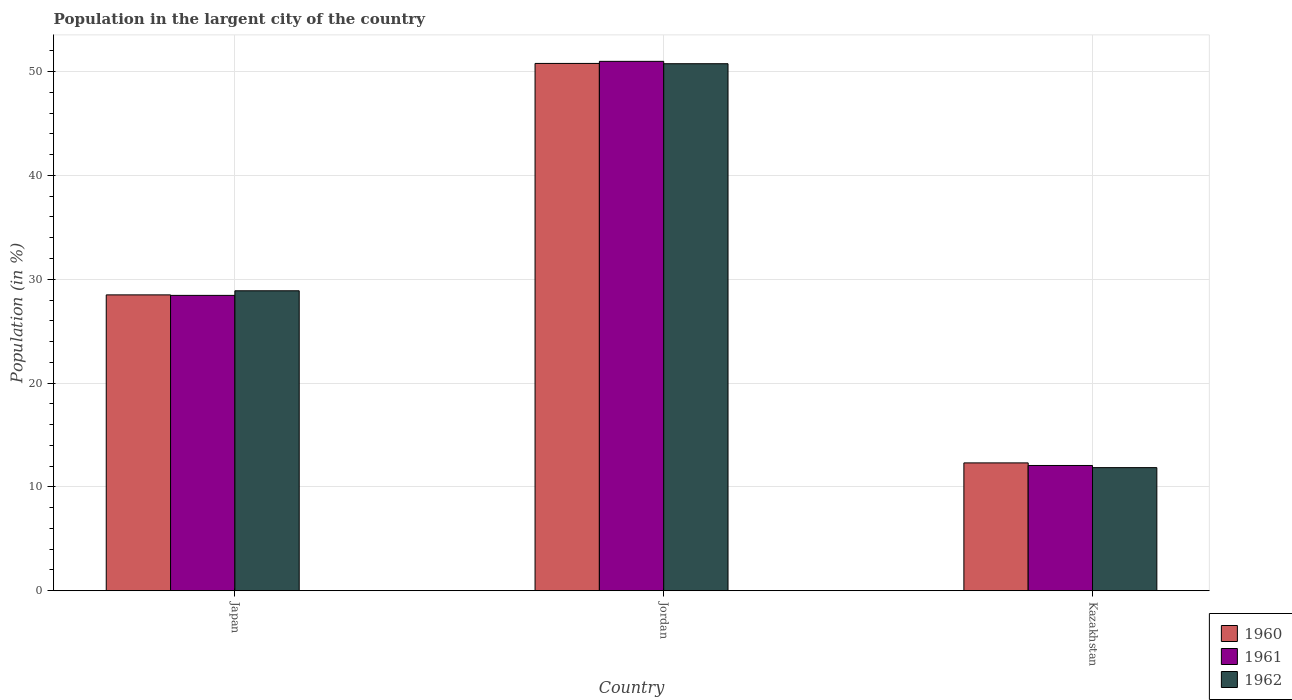How many groups of bars are there?
Provide a short and direct response. 3. Are the number of bars per tick equal to the number of legend labels?
Offer a terse response. Yes. How many bars are there on the 2nd tick from the right?
Ensure brevity in your answer.  3. In how many cases, is the number of bars for a given country not equal to the number of legend labels?
Offer a terse response. 0. What is the percentage of population in the largent city in 1960 in Jordan?
Make the answer very short. 50.79. Across all countries, what is the maximum percentage of population in the largent city in 1962?
Your answer should be very brief. 50.76. Across all countries, what is the minimum percentage of population in the largent city in 1961?
Provide a succinct answer. 12.06. In which country was the percentage of population in the largent city in 1962 maximum?
Your answer should be compact. Jordan. In which country was the percentage of population in the largent city in 1960 minimum?
Offer a terse response. Kazakhstan. What is the total percentage of population in the largent city in 1962 in the graph?
Give a very brief answer. 91.51. What is the difference between the percentage of population in the largent city in 1962 in Japan and that in Jordan?
Ensure brevity in your answer.  -21.87. What is the difference between the percentage of population in the largent city in 1960 in Kazakhstan and the percentage of population in the largent city in 1961 in Japan?
Offer a terse response. -16.14. What is the average percentage of population in the largent city in 1961 per country?
Keep it short and to the point. 30.5. What is the difference between the percentage of population in the largent city of/in 1962 and percentage of population in the largent city of/in 1960 in Kazakhstan?
Give a very brief answer. -0.46. What is the ratio of the percentage of population in the largent city in 1960 in Jordan to that in Kazakhstan?
Ensure brevity in your answer.  4.13. Is the percentage of population in the largent city in 1961 in Japan less than that in Jordan?
Make the answer very short. Yes. What is the difference between the highest and the second highest percentage of population in the largent city in 1961?
Provide a short and direct response. 22.54. What is the difference between the highest and the lowest percentage of population in the largent city in 1961?
Provide a succinct answer. 38.93. Is the sum of the percentage of population in the largent city in 1960 in Japan and Kazakhstan greater than the maximum percentage of population in the largent city in 1961 across all countries?
Provide a succinct answer. No. What does the 3rd bar from the left in Kazakhstan represents?
Offer a very short reply. 1962. What does the 1st bar from the right in Japan represents?
Ensure brevity in your answer.  1962. Are all the bars in the graph horizontal?
Provide a succinct answer. No. What is the difference between two consecutive major ticks on the Y-axis?
Provide a short and direct response. 10. What is the title of the graph?
Provide a succinct answer. Population in the largent city of the country. What is the label or title of the X-axis?
Keep it short and to the point. Country. What is the label or title of the Y-axis?
Your answer should be very brief. Population (in %). What is the Population (in %) in 1960 in Japan?
Your answer should be compact. 28.5. What is the Population (in %) of 1961 in Japan?
Provide a short and direct response. 28.45. What is the Population (in %) of 1962 in Japan?
Ensure brevity in your answer.  28.89. What is the Population (in %) of 1960 in Jordan?
Provide a short and direct response. 50.79. What is the Population (in %) in 1961 in Jordan?
Provide a succinct answer. 50.99. What is the Population (in %) of 1962 in Jordan?
Offer a very short reply. 50.76. What is the Population (in %) in 1960 in Kazakhstan?
Make the answer very short. 12.31. What is the Population (in %) in 1961 in Kazakhstan?
Offer a terse response. 12.06. What is the Population (in %) in 1962 in Kazakhstan?
Give a very brief answer. 11.86. Across all countries, what is the maximum Population (in %) of 1960?
Offer a very short reply. 50.79. Across all countries, what is the maximum Population (in %) in 1961?
Your answer should be compact. 50.99. Across all countries, what is the maximum Population (in %) of 1962?
Your response must be concise. 50.76. Across all countries, what is the minimum Population (in %) in 1960?
Your answer should be compact. 12.31. Across all countries, what is the minimum Population (in %) in 1961?
Ensure brevity in your answer.  12.06. Across all countries, what is the minimum Population (in %) of 1962?
Give a very brief answer. 11.86. What is the total Population (in %) of 1960 in the graph?
Make the answer very short. 91.6. What is the total Population (in %) in 1961 in the graph?
Offer a very short reply. 91.51. What is the total Population (in %) of 1962 in the graph?
Provide a succinct answer. 91.51. What is the difference between the Population (in %) of 1960 in Japan and that in Jordan?
Give a very brief answer. -22.29. What is the difference between the Population (in %) of 1961 in Japan and that in Jordan?
Provide a succinct answer. -22.54. What is the difference between the Population (in %) in 1962 in Japan and that in Jordan?
Offer a very short reply. -21.87. What is the difference between the Population (in %) in 1960 in Japan and that in Kazakhstan?
Provide a short and direct response. 16.18. What is the difference between the Population (in %) in 1961 in Japan and that in Kazakhstan?
Keep it short and to the point. 16.38. What is the difference between the Population (in %) of 1962 in Japan and that in Kazakhstan?
Offer a very short reply. 17.03. What is the difference between the Population (in %) of 1960 in Jordan and that in Kazakhstan?
Make the answer very short. 38.48. What is the difference between the Population (in %) of 1961 in Jordan and that in Kazakhstan?
Ensure brevity in your answer.  38.93. What is the difference between the Population (in %) in 1962 in Jordan and that in Kazakhstan?
Keep it short and to the point. 38.91. What is the difference between the Population (in %) of 1960 in Japan and the Population (in %) of 1961 in Jordan?
Make the answer very short. -22.5. What is the difference between the Population (in %) of 1960 in Japan and the Population (in %) of 1962 in Jordan?
Your answer should be compact. -22.27. What is the difference between the Population (in %) in 1961 in Japan and the Population (in %) in 1962 in Jordan?
Make the answer very short. -22.32. What is the difference between the Population (in %) in 1960 in Japan and the Population (in %) in 1961 in Kazakhstan?
Offer a very short reply. 16.43. What is the difference between the Population (in %) of 1960 in Japan and the Population (in %) of 1962 in Kazakhstan?
Provide a short and direct response. 16.64. What is the difference between the Population (in %) of 1961 in Japan and the Population (in %) of 1962 in Kazakhstan?
Provide a succinct answer. 16.59. What is the difference between the Population (in %) of 1960 in Jordan and the Population (in %) of 1961 in Kazakhstan?
Provide a succinct answer. 38.73. What is the difference between the Population (in %) of 1960 in Jordan and the Population (in %) of 1962 in Kazakhstan?
Make the answer very short. 38.94. What is the difference between the Population (in %) in 1961 in Jordan and the Population (in %) in 1962 in Kazakhstan?
Provide a succinct answer. 39.14. What is the average Population (in %) of 1960 per country?
Offer a terse response. 30.53. What is the average Population (in %) in 1961 per country?
Offer a very short reply. 30.5. What is the average Population (in %) in 1962 per country?
Give a very brief answer. 30.5. What is the difference between the Population (in %) of 1960 and Population (in %) of 1961 in Japan?
Keep it short and to the point. 0.05. What is the difference between the Population (in %) of 1960 and Population (in %) of 1962 in Japan?
Keep it short and to the point. -0.39. What is the difference between the Population (in %) in 1961 and Population (in %) in 1962 in Japan?
Provide a short and direct response. -0.44. What is the difference between the Population (in %) of 1960 and Population (in %) of 1961 in Jordan?
Your response must be concise. -0.2. What is the difference between the Population (in %) in 1960 and Population (in %) in 1962 in Jordan?
Provide a short and direct response. 0.03. What is the difference between the Population (in %) of 1961 and Population (in %) of 1962 in Jordan?
Provide a short and direct response. 0.23. What is the difference between the Population (in %) in 1960 and Population (in %) in 1961 in Kazakhstan?
Give a very brief answer. 0.25. What is the difference between the Population (in %) of 1960 and Population (in %) of 1962 in Kazakhstan?
Offer a terse response. 0.46. What is the difference between the Population (in %) of 1961 and Population (in %) of 1962 in Kazakhstan?
Offer a very short reply. 0.21. What is the ratio of the Population (in %) in 1960 in Japan to that in Jordan?
Keep it short and to the point. 0.56. What is the ratio of the Population (in %) in 1961 in Japan to that in Jordan?
Give a very brief answer. 0.56. What is the ratio of the Population (in %) in 1962 in Japan to that in Jordan?
Offer a very short reply. 0.57. What is the ratio of the Population (in %) of 1960 in Japan to that in Kazakhstan?
Your answer should be compact. 2.31. What is the ratio of the Population (in %) in 1961 in Japan to that in Kazakhstan?
Provide a succinct answer. 2.36. What is the ratio of the Population (in %) in 1962 in Japan to that in Kazakhstan?
Offer a very short reply. 2.44. What is the ratio of the Population (in %) in 1960 in Jordan to that in Kazakhstan?
Offer a very short reply. 4.13. What is the ratio of the Population (in %) in 1961 in Jordan to that in Kazakhstan?
Ensure brevity in your answer.  4.23. What is the ratio of the Population (in %) in 1962 in Jordan to that in Kazakhstan?
Your answer should be compact. 4.28. What is the difference between the highest and the second highest Population (in %) of 1960?
Your answer should be compact. 22.29. What is the difference between the highest and the second highest Population (in %) of 1961?
Ensure brevity in your answer.  22.54. What is the difference between the highest and the second highest Population (in %) of 1962?
Ensure brevity in your answer.  21.87. What is the difference between the highest and the lowest Population (in %) in 1960?
Make the answer very short. 38.48. What is the difference between the highest and the lowest Population (in %) in 1961?
Your answer should be very brief. 38.93. What is the difference between the highest and the lowest Population (in %) in 1962?
Make the answer very short. 38.91. 